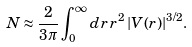Convert formula to latex. <formula><loc_0><loc_0><loc_500><loc_500>N \approx \frac { 2 } { 3 \pi } \int _ { 0 } ^ { \infty } d r \, r ^ { 2 } \, | V ( r ) | ^ { 3 / 2 } .</formula> 